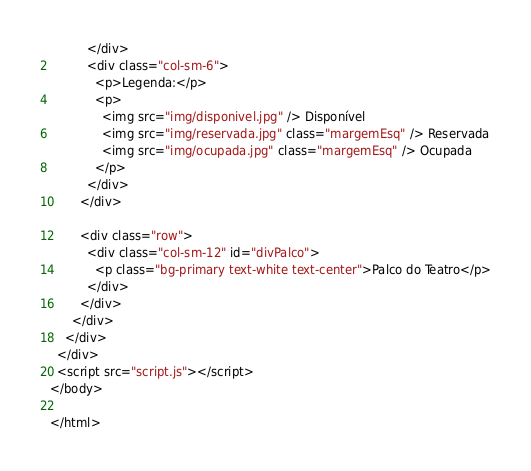<code> <loc_0><loc_0><loc_500><loc_500><_HTML_>          </div>
          <div class="col-sm-6">
            <p>Legenda:</p>
            <p>
              <img src="img/disponivel.jpg" /> Disponível
              <img src="img/reservada.jpg" class="margemEsq" /> Reservada
              <img src="img/ocupada.jpg" class="margemEsq" /> Ocupada
            </p>
          </div>
        </div>

        <div class="row">
          <div class="col-sm-12" id="divPalco">
            <p class="bg-primary text-white text-center">Palco do Teatro</p>
          </div>
        </div>
      </div>
    </div>
  </div>
  <script src="script.js"></script>
</body>

</html></code> 